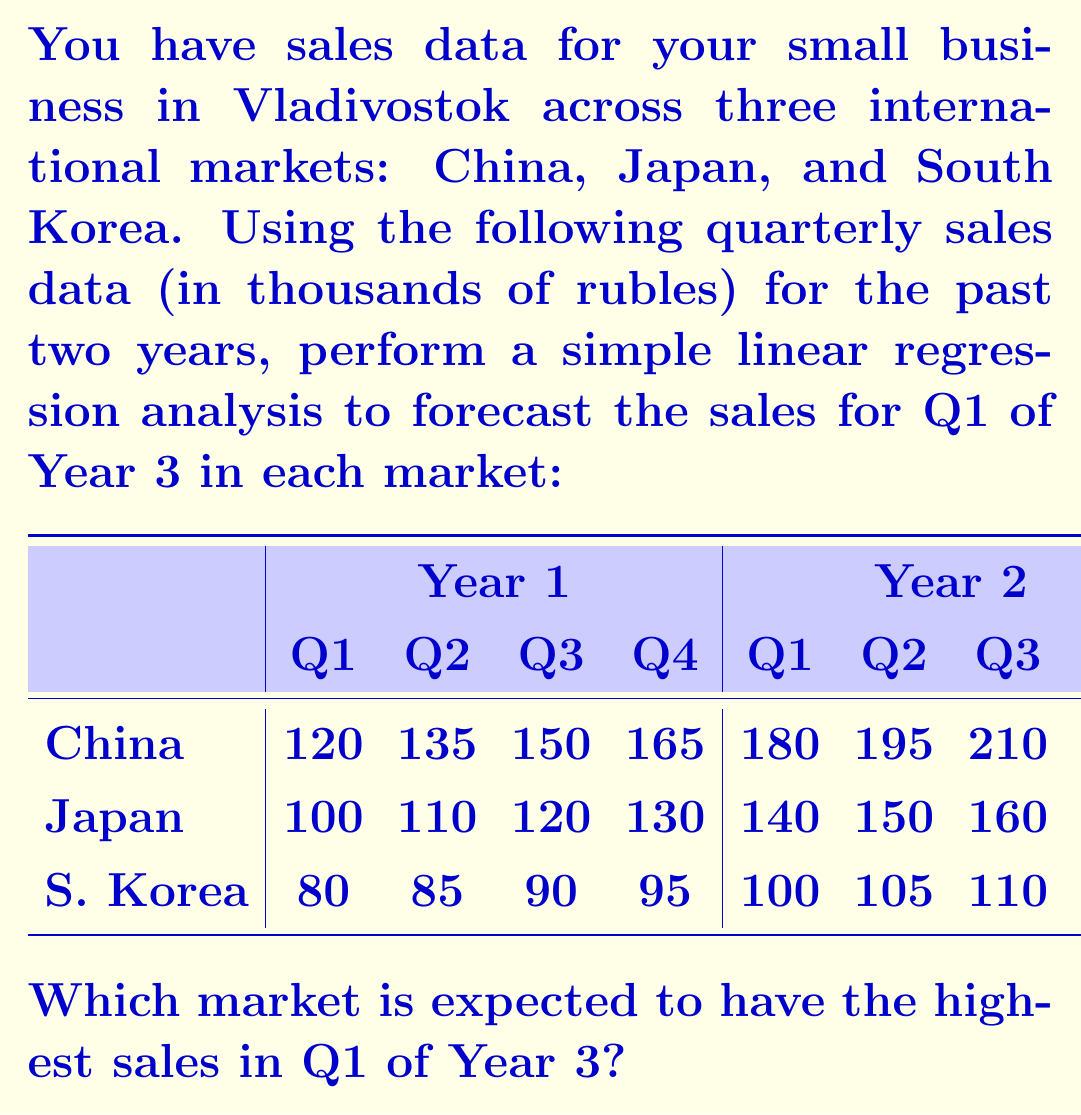Solve this math problem. To forecast sales for Q1 of Year 3 in each market, we'll use simple linear regression. The general form of the equation is:

$$ y = mx + b $$

Where $y$ is the sales, $x$ is the time period, $m$ is the slope, and $b$ is the y-intercept.

Step 1: Assign time periods (x-values) to each quarter, starting with 1 for Q1 of Year 1 and ending with 8 for Q4 of Year 2.

Step 2: Calculate the slope (m) and y-intercept (b) for each market using the following formulas:

$$ m = \frac{n\sum xy - \sum x \sum y}{n\sum x^2 - (\sum x)^2} $$
$$ b = \frac{\sum y - m\sum x}{n} $$

Where $n$ is the number of data points (8 in this case).

Step 3: Calculate the regression line equation for each market.

For China:
$m = 15$, $b = 105$
Equation: $y = 15x + 105$

For Japan:
$m = 10$, $b = 90$
Equation: $y = 10x + 90$

For South Korea:
$m = 5$, $b = 75$
Equation: $y = 5x + 75$

Step 4: Use the equations to forecast sales for Q1 of Year 3 (x = 9):

China: $y = 15(9) + 105 = 240$
Japan: $y = 10(9) + 90 = 180$
South Korea: $y = 5(9) + 75 = 120$

Therefore, China is expected to have the highest sales in Q1 of Year 3 with 240,000 rubles.
Answer: China 